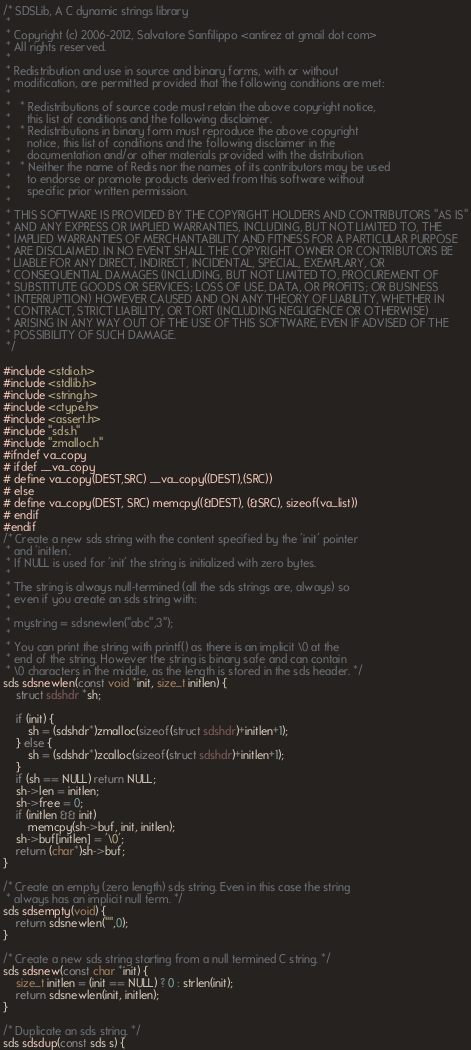<code> <loc_0><loc_0><loc_500><loc_500><_C++_>/* SDSLib, A C dynamic strings library
 *
 * Copyright (c) 2006-2012, Salvatore Sanfilippo <antirez at gmail dot com>
 * All rights reserved.
 *
 * Redistribution and use in source and binary forms, with or without
 * modification, are permitted provided that the following conditions are met:
 *
 *   * Redistributions of source code must retain the above copyright notice,
 *     this list of conditions and the following disclaimer.
 *   * Redistributions in binary form must reproduce the above copyright
 *     notice, this list of conditions and the following disclaimer in the
 *     documentation and/or other materials provided with the distribution.
 *   * Neither the name of Redis nor the names of its contributors may be used
 *     to endorse or promote products derived from this software without
 *     specific prior written permission.
 *
 * THIS SOFTWARE IS PROVIDED BY THE COPYRIGHT HOLDERS AND CONTRIBUTORS "AS IS"
 * AND ANY EXPRESS OR IMPLIED WARRANTIES, INCLUDING, BUT NOT LIMITED TO, THE
 * IMPLIED WARRANTIES OF MERCHANTABILITY AND FITNESS FOR A PARTICULAR PURPOSE
 * ARE DISCLAIMED. IN NO EVENT SHALL THE COPYRIGHT OWNER OR CONTRIBUTORS BE
 * LIABLE FOR ANY DIRECT, INDIRECT, INCIDENTAL, SPECIAL, EXEMPLARY, OR
 * CONSEQUENTIAL DAMAGES (INCLUDING, BUT NOT LIMITED TO, PROCUREMENT OF
 * SUBSTITUTE GOODS OR SERVICES; LOSS OF USE, DATA, OR PROFITS; OR BUSINESS
 * INTERRUPTION) HOWEVER CAUSED AND ON ANY THEORY OF LIABILITY, WHETHER IN
 * CONTRACT, STRICT LIABILITY, OR TORT (INCLUDING NEGLIGENCE OR OTHERWISE)
 * ARISING IN ANY WAY OUT OF THE USE OF THIS SOFTWARE, EVEN IF ADVISED OF THE
 * POSSIBILITY OF SUCH DAMAGE.
 */

#include <stdio.h>
#include <stdlib.h>
#include <string.h>
#include <ctype.h>
#include <assert.h>
#include "sds.h"
#include "zmalloc.h"
#ifndef va_copy 
# ifdef __va_copy 
# define va_copy(DEST,SRC) __va_copy((DEST),(SRC)) 
# else 
# define va_copy(DEST, SRC) memcpy((&DEST), (&SRC), sizeof(va_list)) 
# endif 
#endif
/* Create a new sds string with the content specified by the 'init' pointer
 * and 'initlen'.
 * If NULL is used for 'init' the string is initialized with zero bytes.
 *
 * The string is always null-termined (all the sds strings are, always) so
 * even if you create an sds string with:
 *
 * mystring = sdsnewlen("abc",3");
 *
 * You can print the string with printf() as there is an implicit \0 at the
 * end of the string. However the string is binary safe and can contain
 * \0 characters in the middle, as the length is stored in the sds header. */
sds sdsnewlen(const void *init, size_t initlen) {
    struct sdshdr *sh;

    if (init) {
        sh = (sdshdr*)zmalloc(sizeof(struct sdshdr)+initlen+1);
    } else {
        sh = (sdshdr*)zcalloc(sizeof(struct sdshdr)+initlen+1);
    }
    if (sh == NULL) return NULL;
    sh->len = initlen;
    sh->free = 0;
    if (initlen && init)
        memcpy(sh->buf, init, initlen);
    sh->buf[initlen] = '\0';
    return (char*)sh->buf;
}

/* Create an empty (zero length) sds string. Even in this case the string
 * always has an implicit null term. */
sds sdsempty(void) {
    return sdsnewlen("",0);
}

/* Create a new sds string starting from a null termined C string. */
sds sdsnew(const char *init) {
    size_t initlen = (init == NULL) ? 0 : strlen(init);
    return sdsnewlen(init, initlen);
}

/* Duplicate an sds string. */
sds sdsdup(const sds s) {</code> 